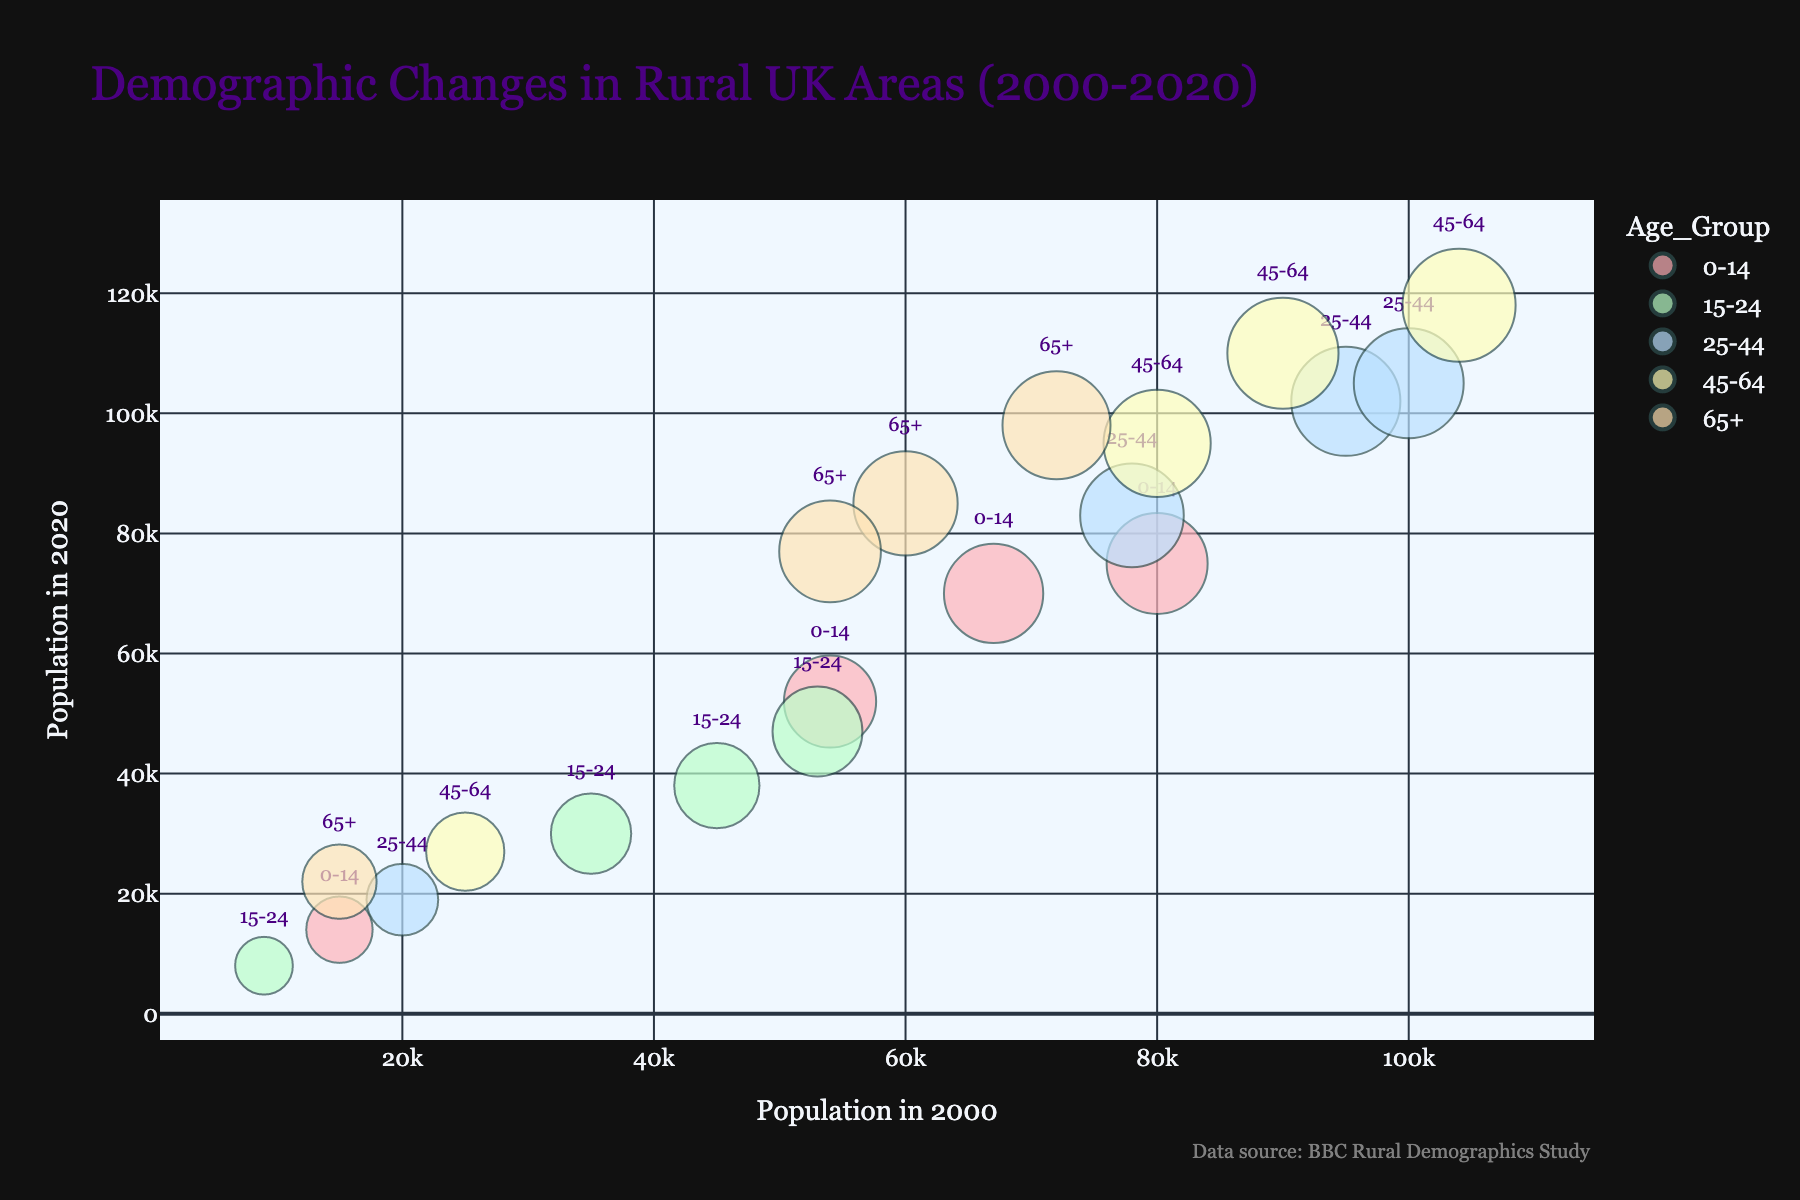what is the title of the plot? The title of the plot is displayed at the top and provides a summary of what the visualization represents.
Answer: Demographic Changes in Rural UK Areas (2000-2020) How many age groups are represented in the chart? The chart uses different colors to represent distinct age groups, and the legend lists all these groups.
Answer: Five Which region has the highest growth rate for the 65+ age group? Look for the bubble representing the 65+ age group in each region and identify the one with the highest y-axis position (Population in 2020).
Answer: Lake District What is the population change for the 0-14 age group in Devon from 2000 to 2020? Locate the bubbles for the 0-14 age group in Devon. Compare the x-axis value (Population in 2000) with the y-axis value (Population in 2020) and calculate the difference.
Answer: -5000 Which age group in Norfolk had a population decline from 2000 to 2020? Identify the bubbles for Norfolk, and compare the x-axis and y-axis values. The group showing a decrease in population will have a lower y-axis value than x-axis value.
Answer: 0-14 and 15-24 In which age group did Cornwall experience the highest growth rate? Compare the growth rates shown in the chart for each age group in Cornwall and identify the largest value.
Answer: 65+ How does the population change for the 25-44 age group in the Lake District compare to Norfolk? Locate the corresponding bubbles for the 25-44 age group in both regions, compare their x-axis (Population in 2000) value to y-axis value (Population in 2020), and observe the differences.
Answer: Lake District: decrease; Norfolk: increase What is the average growth rate for the 45-64 age group across all regions? Calculate the individual growth rates for the 45-64 age group in each region and then find their average.
Answer: 15.625 How does the population trend for the 15-24 age group across all regions appear in the chart? Analyze the position of bubbles, noting the x-axis (Population in 2000) and y-axis (Population in 2020) values for the 15-24 age group, and observe the overall trend direction.
Answer: Decrease 